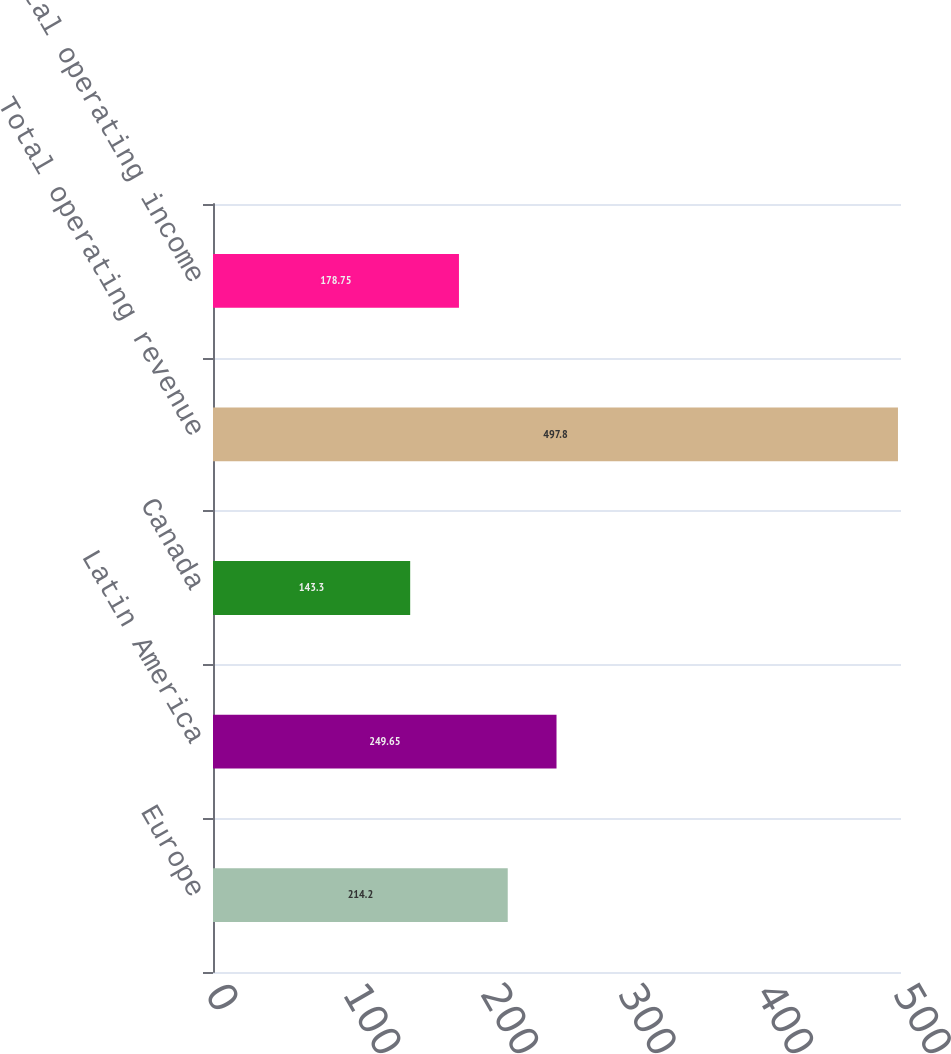<chart> <loc_0><loc_0><loc_500><loc_500><bar_chart><fcel>Europe<fcel>Latin America<fcel>Canada<fcel>Total operating revenue<fcel>Total operating income<nl><fcel>214.2<fcel>249.65<fcel>143.3<fcel>497.8<fcel>178.75<nl></chart> 